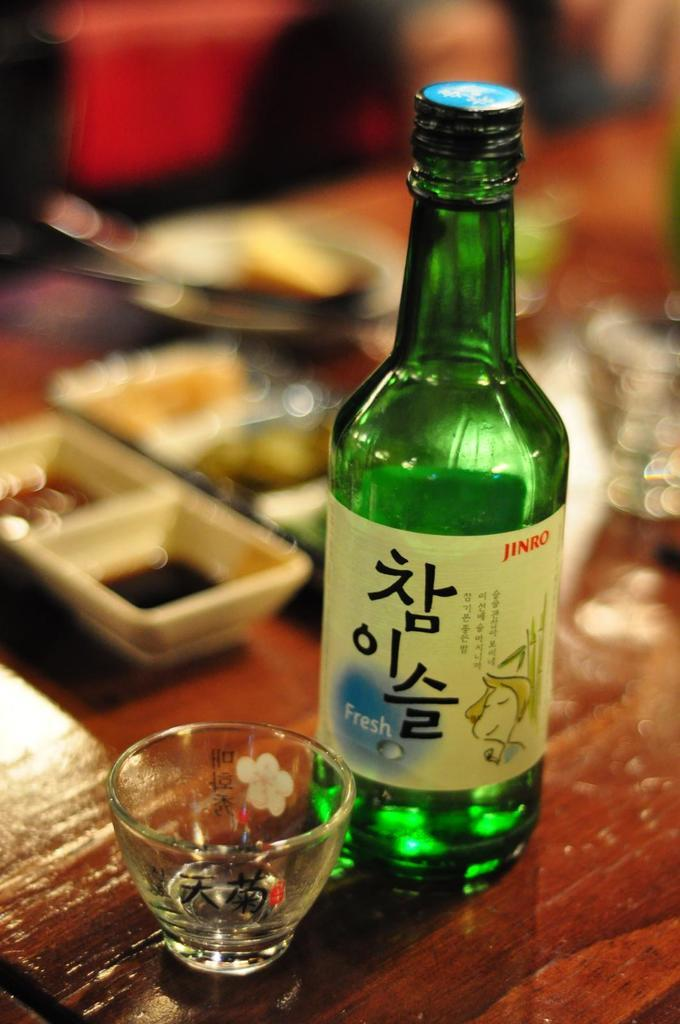<image>
Summarize the visual content of the image. A glass bottle of liquid with the word fresh on the side 